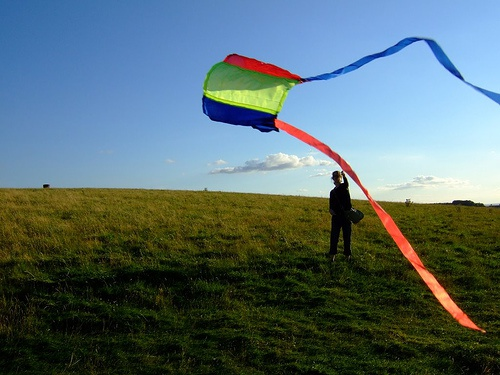Describe the objects in this image and their specific colors. I can see kite in blue, navy, green, and salmon tones, people in blue, black, darkgreen, and gray tones, and handbag in blue, black, olive, and gray tones in this image. 